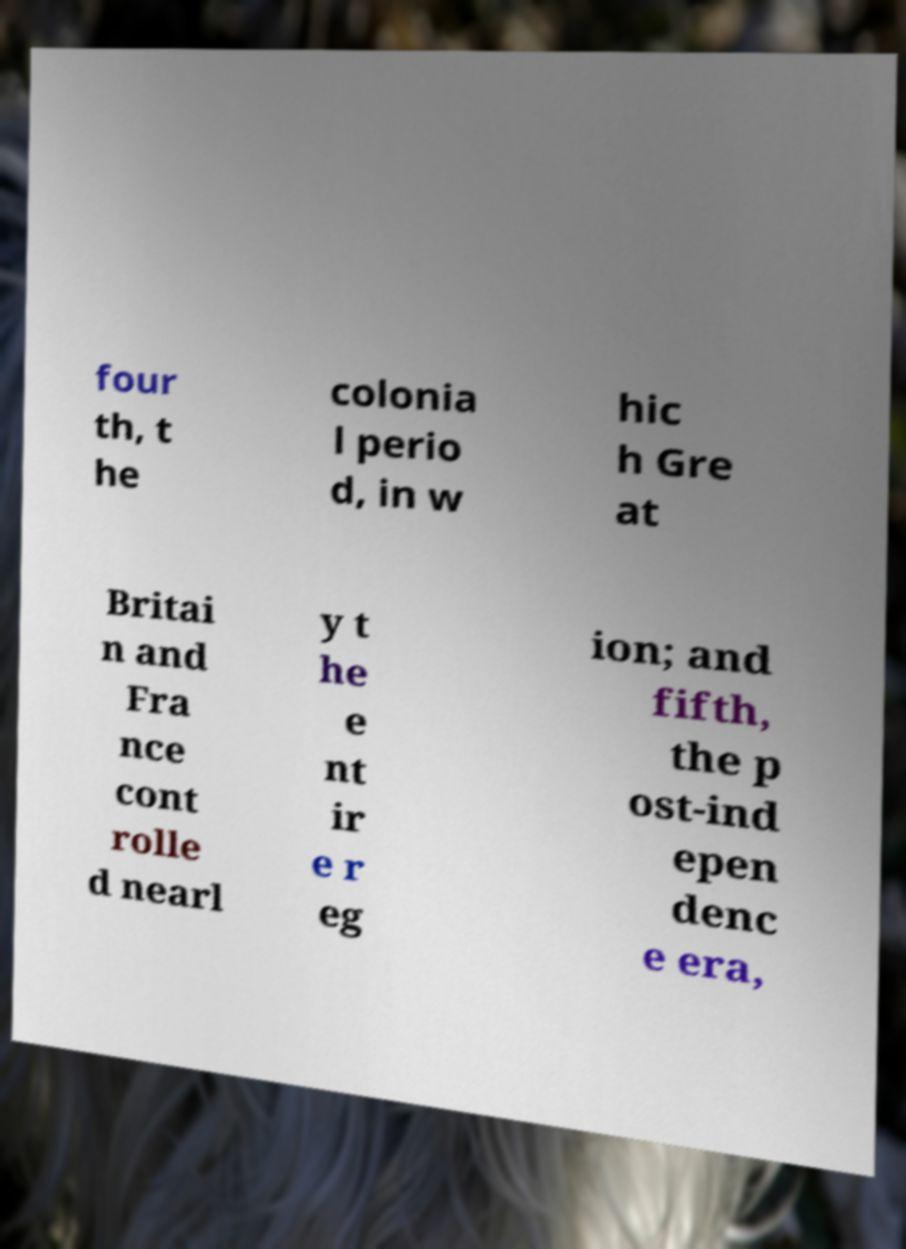There's text embedded in this image that I need extracted. Can you transcribe it verbatim? four th, t he colonia l perio d, in w hic h Gre at Britai n and Fra nce cont rolle d nearl y t he e nt ir e r eg ion; and fifth, the p ost-ind epen denc e era, 